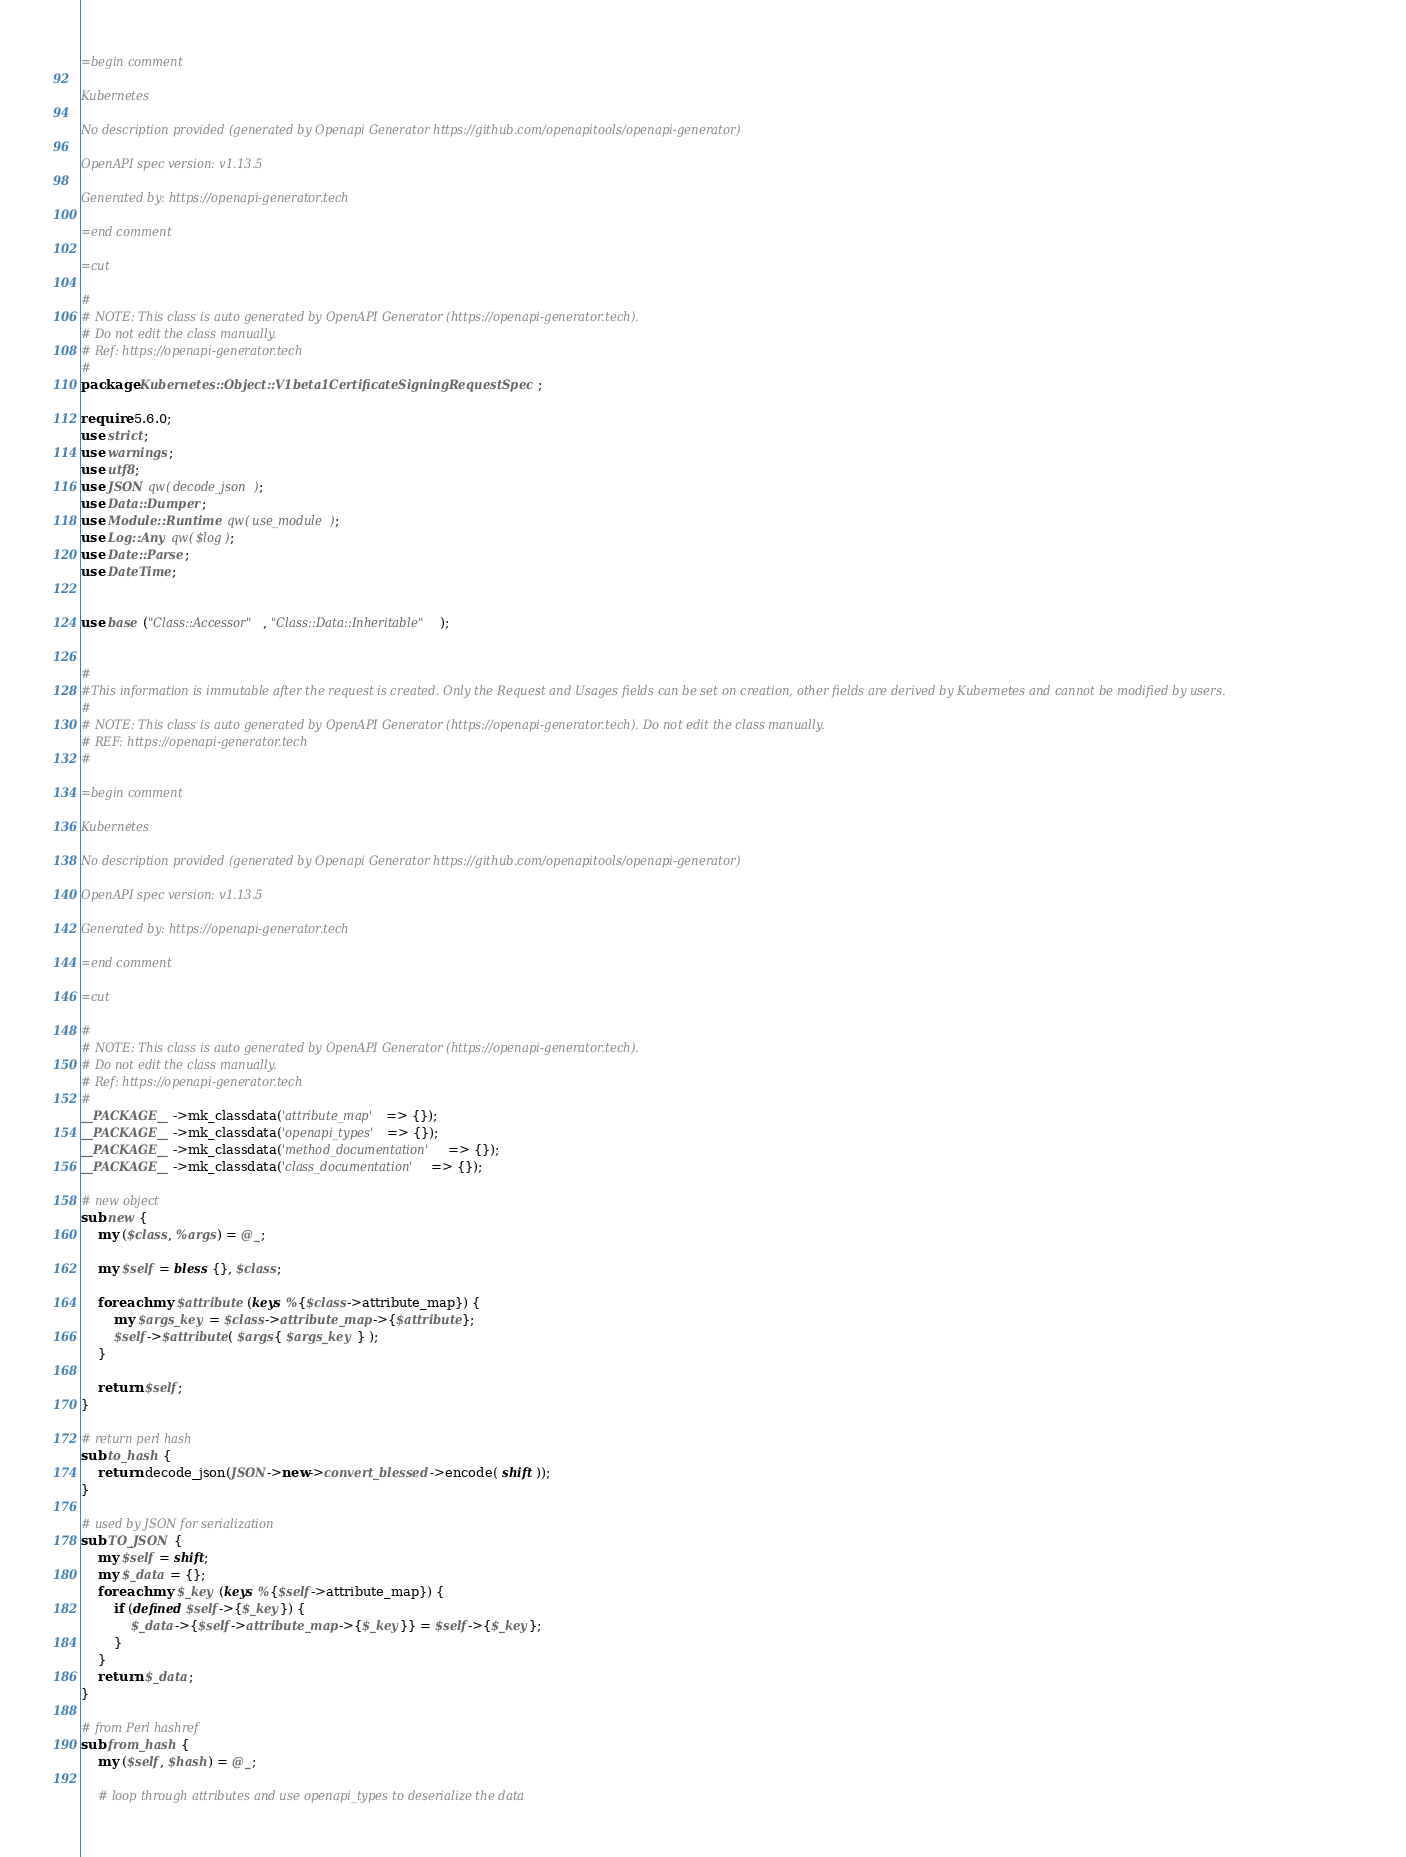<code> <loc_0><loc_0><loc_500><loc_500><_Perl_>=begin comment

Kubernetes

No description provided (generated by Openapi Generator https://github.com/openapitools/openapi-generator)

OpenAPI spec version: v1.13.5

Generated by: https://openapi-generator.tech

=end comment

=cut

#
# NOTE: This class is auto generated by OpenAPI Generator (https://openapi-generator.tech).
# Do not edit the class manually.
# Ref: https://openapi-generator.tech
#
package Kubernetes::Object::V1beta1CertificateSigningRequestSpec;

require 5.6.0;
use strict;
use warnings;
use utf8;
use JSON qw(decode_json);
use Data::Dumper;
use Module::Runtime qw(use_module);
use Log::Any qw($log);
use Date::Parse;
use DateTime;


use base ("Class::Accessor", "Class::Data::Inheritable");


#
#This information is immutable after the request is created. Only the Request and Usages fields can be set on creation, other fields are derived by Kubernetes and cannot be modified by users.
#
# NOTE: This class is auto generated by OpenAPI Generator (https://openapi-generator.tech). Do not edit the class manually.
# REF: https://openapi-generator.tech
#

=begin comment

Kubernetes

No description provided (generated by Openapi Generator https://github.com/openapitools/openapi-generator)

OpenAPI spec version: v1.13.5

Generated by: https://openapi-generator.tech

=end comment

=cut

#
# NOTE: This class is auto generated by OpenAPI Generator (https://openapi-generator.tech).
# Do not edit the class manually.
# Ref: https://openapi-generator.tech
#
__PACKAGE__->mk_classdata('attribute_map' => {});
__PACKAGE__->mk_classdata('openapi_types' => {});
__PACKAGE__->mk_classdata('method_documentation' => {}); 
__PACKAGE__->mk_classdata('class_documentation' => {});

# new object
sub new { 
    my ($class, %args) = @_; 

	my $self = bless {}, $class;
	
	foreach my $attribute (keys %{$class->attribute_map}) {
		my $args_key = $class->attribute_map->{$attribute};
		$self->$attribute( $args{ $args_key } );
	}
	
	return $self;
}  

# return perl hash
sub to_hash {
    return decode_json(JSON->new->convert_blessed->encode( shift ));
}

# used by JSON for serialization
sub TO_JSON { 
    my $self = shift;
    my $_data = {};
    foreach my $_key (keys %{$self->attribute_map}) {
        if (defined $self->{$_key}) {
            $_data->{$self->attribute_map->{$_key}} = $self->{$_key};
        }
    }
    return $_data;
}

# from Perl hashref
sub from_hash {
    my ($self, $hash) = @_;

    # loop through attributes and use openapi_types to deserialize the data</code> 